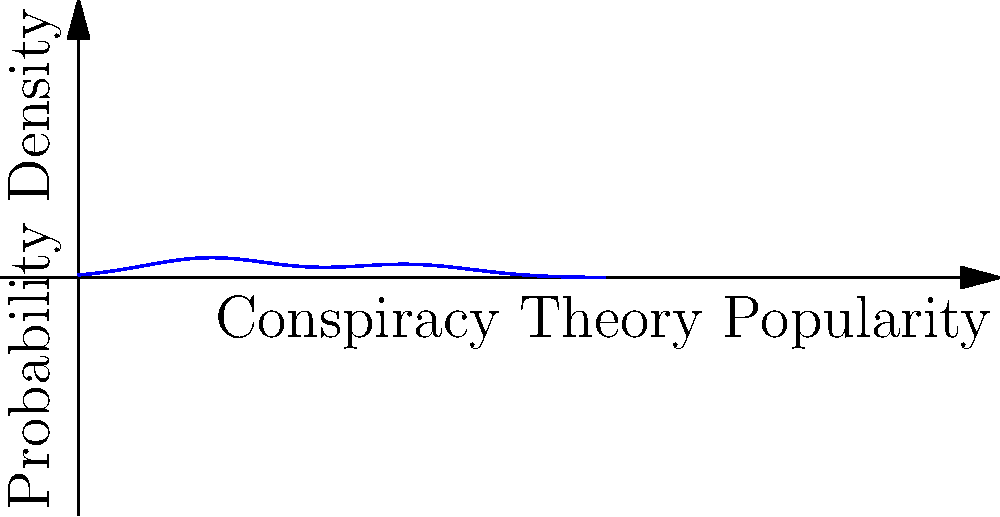The graph above represents the probability density function of the popularity of internet conspiracy theories. If the area under the entire curve represents all conspiracy theories, what does the area under peak B likely represent in comparison to peak A? To answer this question, we need to analyze the probability density function (PDF) shown in the graph:

1. The graph shows a bimodal distribution, with two distinct peaks (A and B).

2. In a PDF, the area under the curve represents the probability of an event occurring within that range.

3. Peak A (around x=2) is higher and narrower than peak B (around x=5).

4. However, peak B, while lower, is wider than peak A.

5. The area under a curve is determined by both its height and width.

6. Given that peak B is wider, it's likely that the area under it is larger than the area under peak A, despite being shorter.

7. In the context of conspiracy theories, a wider peak suggests a more diverse range of theories with similar popularity levels.

8. Therefore, peak B likely represents a larger group of conspiracy theories that are moderately popular, while peak A represents a smaller group of highly popular theories.
Answer: A larger, more diverse group of moderately popular conspiracy theories 